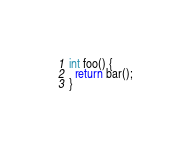Convert code to text. <code><loc_0><loc_0><loc_500><loc_500><_C++_>int foo() {
  return bar();
}
</code> 